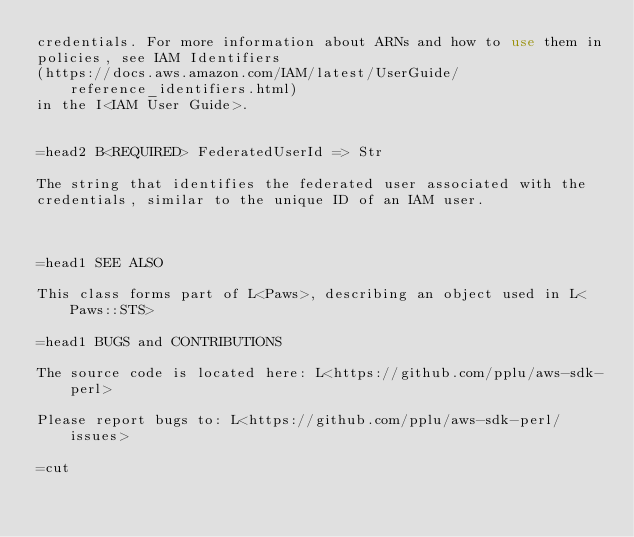Convert code to text. <code><loc_0><loc_0><loc_500><loc_500><_Perl_>credentials. For more information about ARNs and how to use them in
policies, see IAM Identifiers
(https://docs.aws.amazon.com/IAM/latest/UserGuide/reference_identifiers.html)
in the I<IAM User Guide>.


=head2 B<REQUIRED> FederatedUserId => Str

The string that identifies the federated user associated with the
credentials, similar to the unique ID of an IAM user.



=head1 SEE ALSO

This class forms part of L<Paws>, describing an object used in L<Paws::STS>

=head1 BUGS and CONTRIBUTIONS

The source code is located here: L<https://github.com/pplu/aws-sdk-perl>

Please report bugs to: L<https://github.com/pplu/aws-sdk-perl/issues>

=cut

</code> 